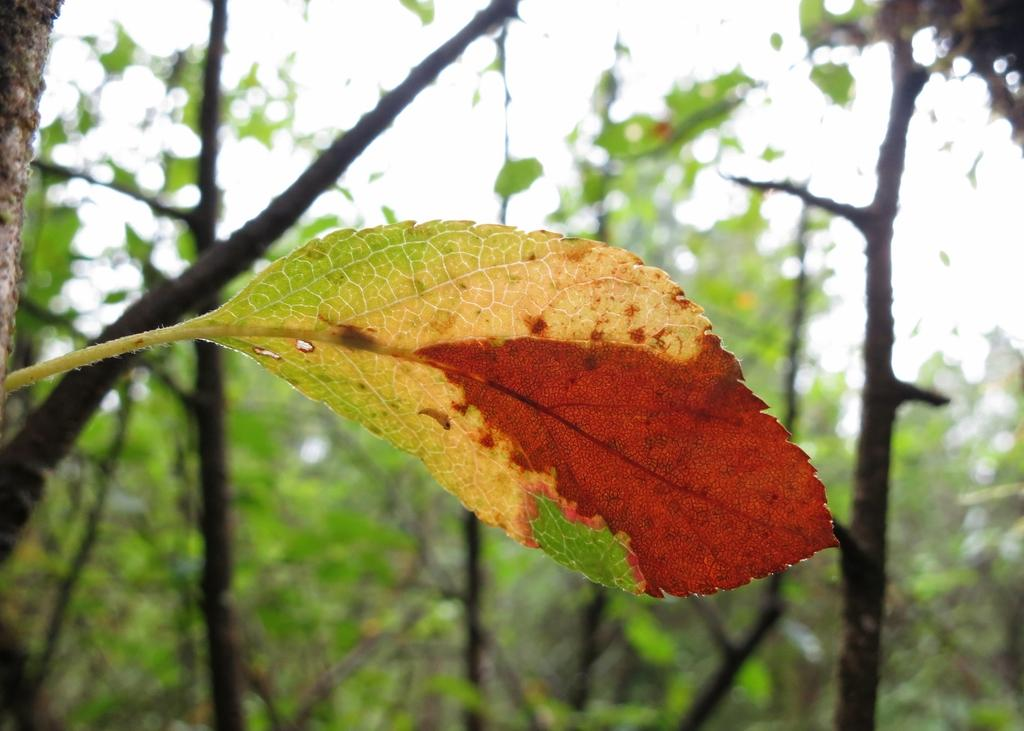What is the main object in the front of the image? There is a leaf in the front of the image. What can be seen in the background of the image? There are multiple trees in the background of the image. How would you describe the appearance of the background? The background is blurry. How many fictional lines can be seen in the image? There are no fictional lines present in the image. Can you describe the movement of the fly in the image? There is no fly present in the image. 